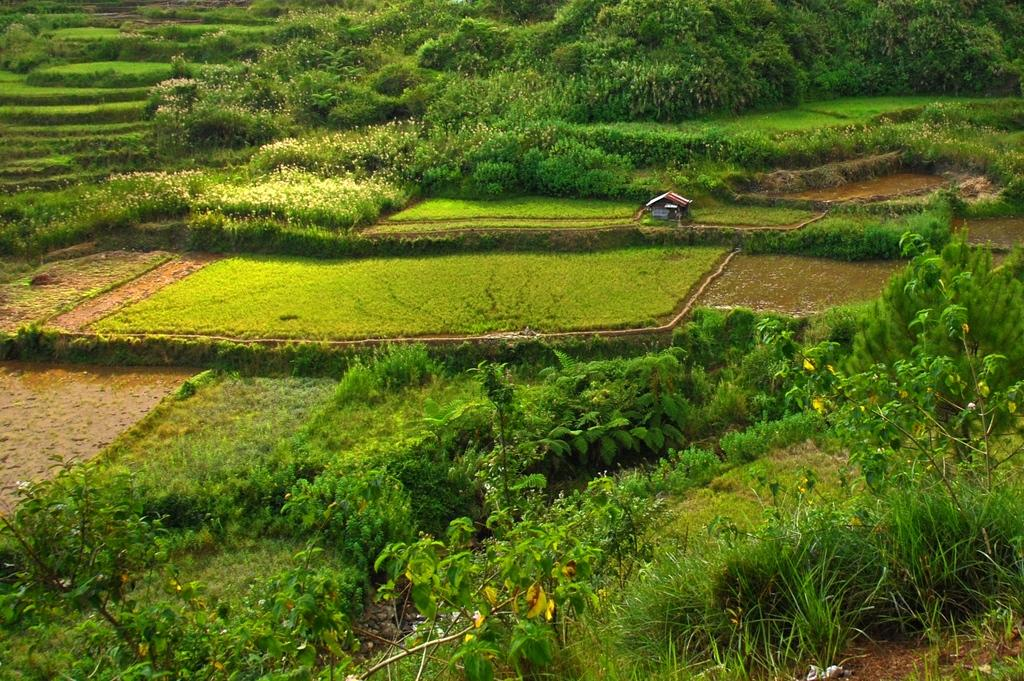What type of vegetation can be seen in the image? There are trees and plants in the image. What type of structure is present in the image? There is a house in the image. Where is the group of people working in the office located in the image? There is no group of people working in an office present in the image; it features trees, plants, and a house. What type of gardening tool, such as a spade, can be seen in the image? There is no gardening tool, such as a spade, present in the image. 